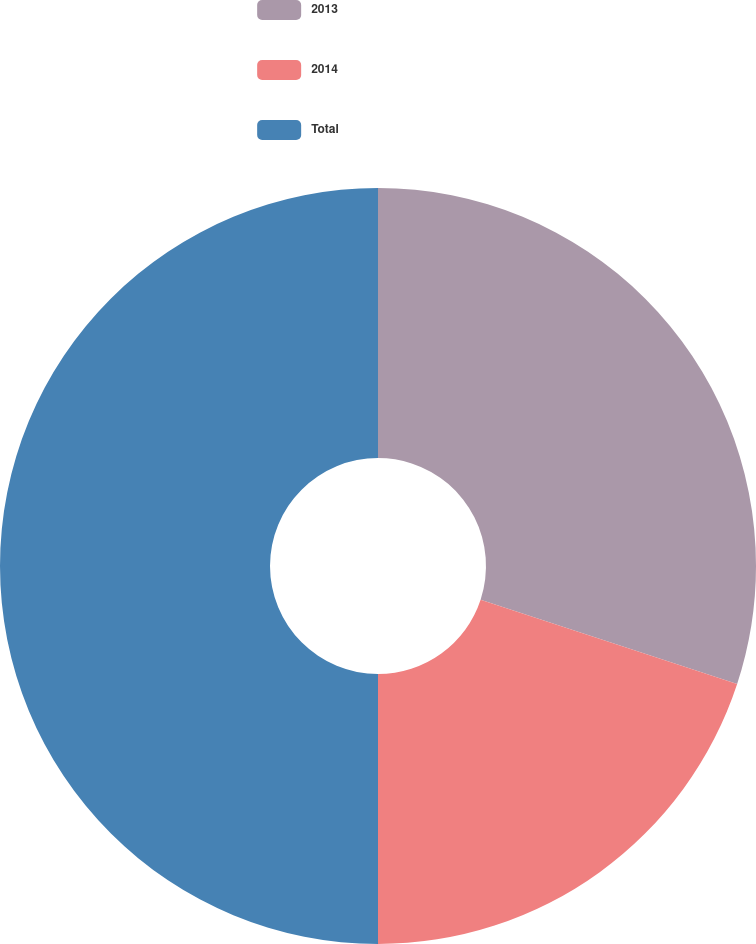Convert chart to OTSL. <chart><loc_0><loc_0><loc_500><loc_500><pie_chart><fcel>2013<fcel>2014<fcel>Total<nl><fcel>30.05%<fcel>19.95%<fcel>50.0%<nl></chart> 